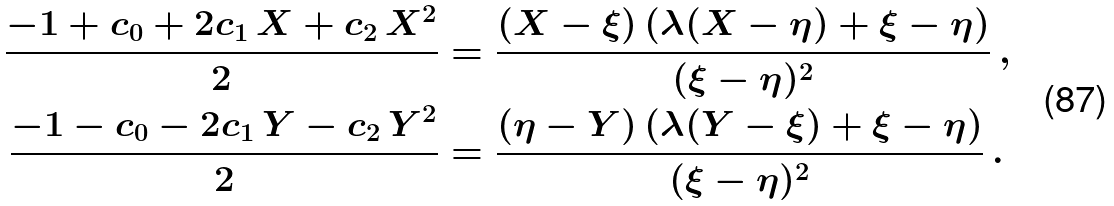<formula> <loc_0><loc_0><loc_500><loc_500>\frac { - 1 + c _ { 0 } + 2 c _ { 1 } \, X + c _ { 2 } \, X ^ { 2 } } 2 & = \frac { ( X - \xi ) \left ( \lambda ( X - \eta ) + \xi - \eta \right ) } { ( \xi - \eta ) ^ { 2 } } \, , \\ \frac { - 1 - c _ { 0 } - 2 c _ { 1 } \, Y - c _ { 2 } \, Y ^ { 2 } } 2 & = \frac { ( \eta - Y ) \left ( \lambda ( Y - \xi ) + \xi - \eta \right ) } { ( \xi - \eta ) ^ { 2 } } \, .</formula> 